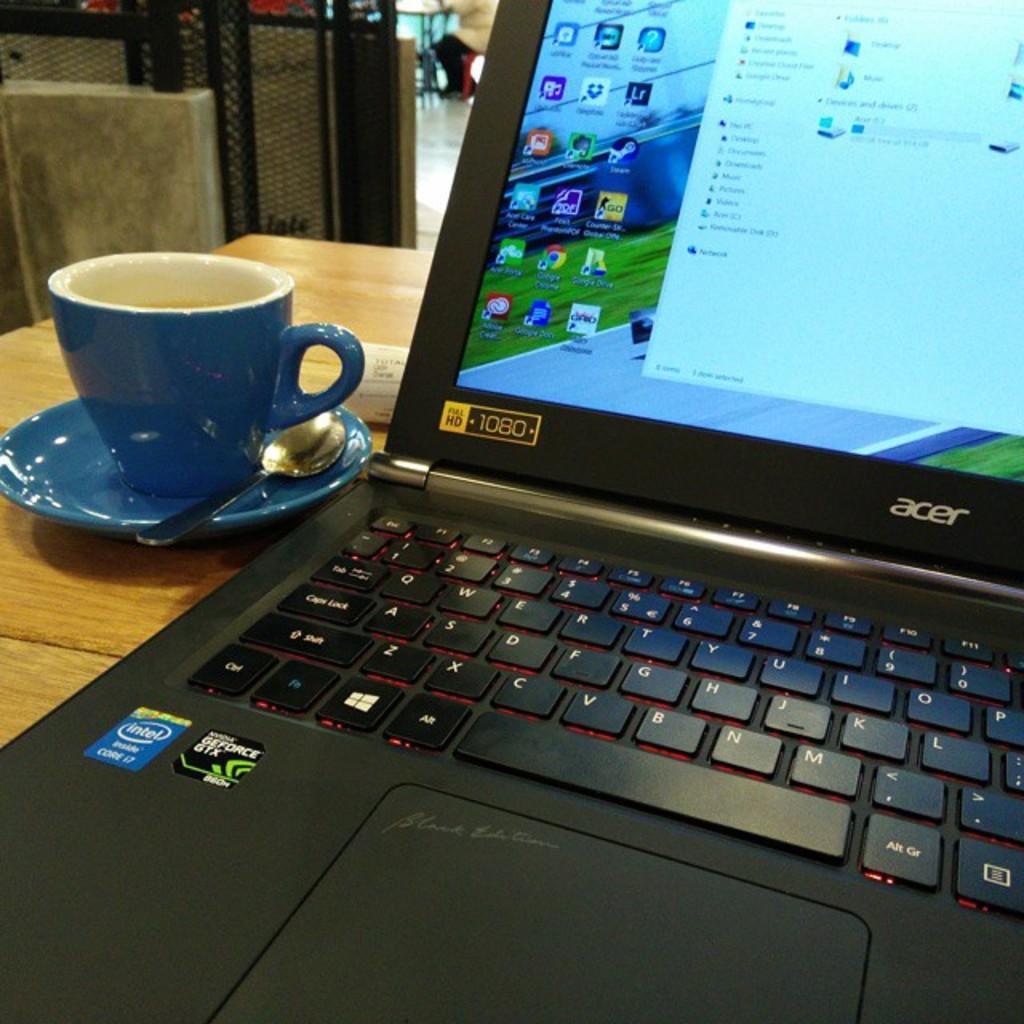Could you give a brief overview of what you see in this image? In this image we can see a laptop, cup and spoon on a saucer and a paper are on the table. In the background we can see mesh, objects and a person is sitting on the chair at the table on the floor. 